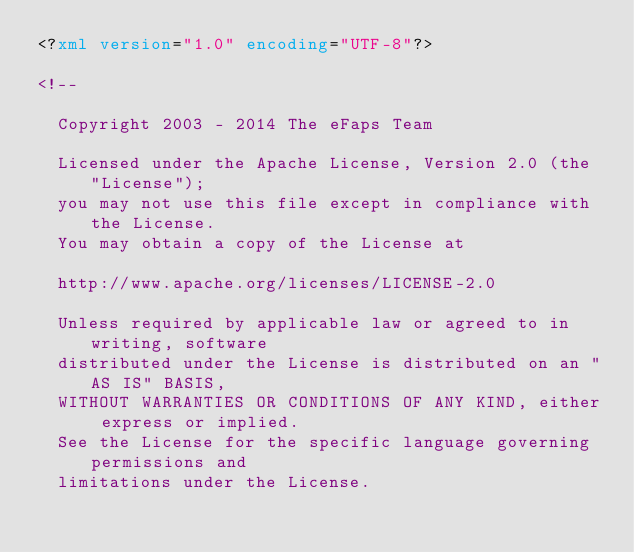<code> <loc_0><loc_0><loc_500><loc_500><_XML_><?xml version="1.0" encoding="UTF-8"?>

<!--

  Copyright 2003 - 2014 The eFaps Team

  Licensed under the Apache License, Version 2.0 (the "License");
  you may not use this file except in compliance with the License.
  You may obtain a copy of the License at

  http://www.apache.org/licenses/LICENSE-2.0

  Unless required by applicable law or agreed to in writing, software
  distributed under the License is distributed on an "AS IS" BASIS,
  WITHOUT WARRANTIES OR CONDITIONS OF ANY KIND, either express or implied.
  See the License for the specific language governing permissions and
  limitations under the License.
</code> 